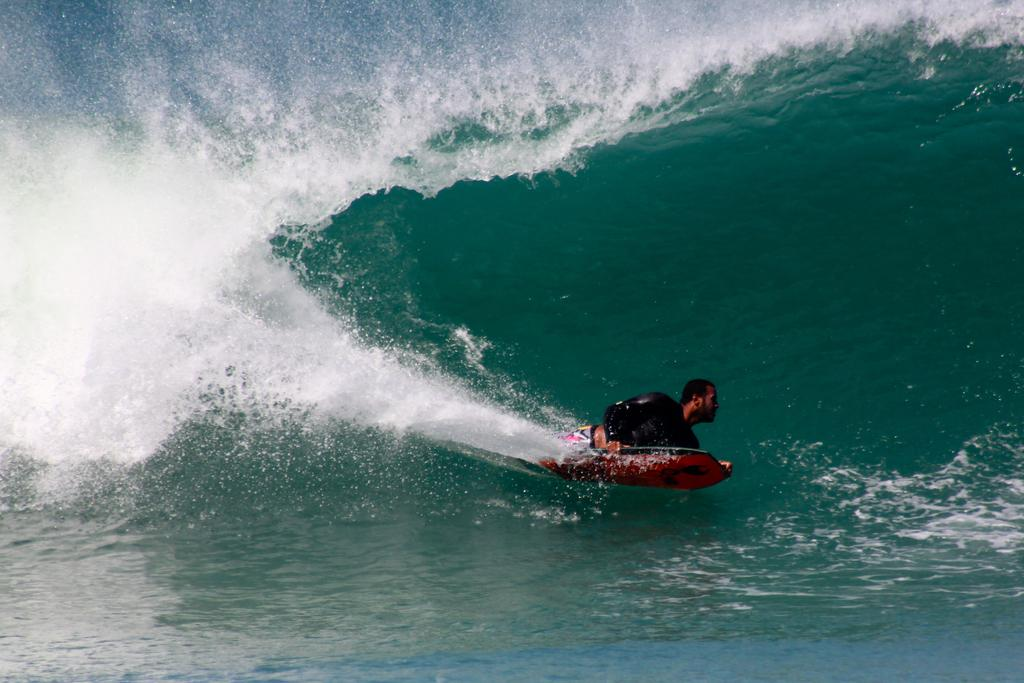Who is present in the image? There is a man in the image. What is the man wearing? The man is wearing clothes. How is the man traveling in the image? The man is riding on the water. What is the man using to ride on the water? The man is using a water board to ride on the water. What type of environment is depicted in the image? The image depicts a water-based environment. What type of poison is the man using to ride on the water? There is no poison present in the image; the man is using a water board to ride on the water. Can you see an umbrella in the image? There is no umbrella present in the image. 